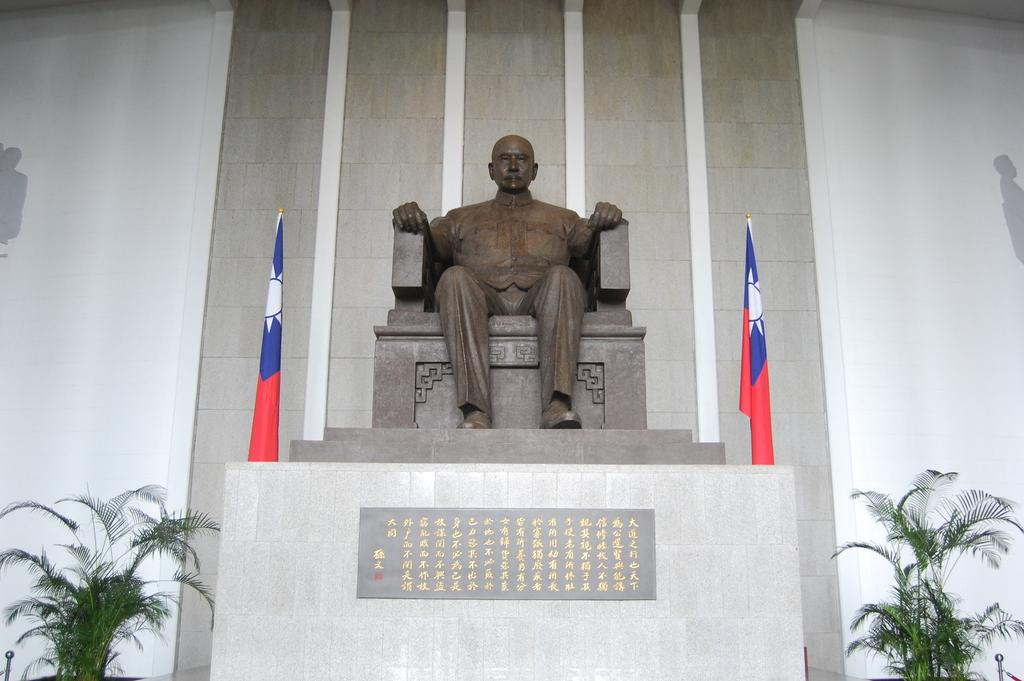What type of structure can be seen in the image? There is a wall in the image. What is located near the wall? There is a statue and flags in the image. Are there any plants visible in the image? Yes, there are plants in the bottom left and bottom right of the image. What type of nut is being used to level the statue in the image? There is no nut or leveling process depicted in the image; the statue is stationary. How does the statue achieve self-awareness in the image? The statue is an inanimate object and does not have the ability to achieve self-awareness. 